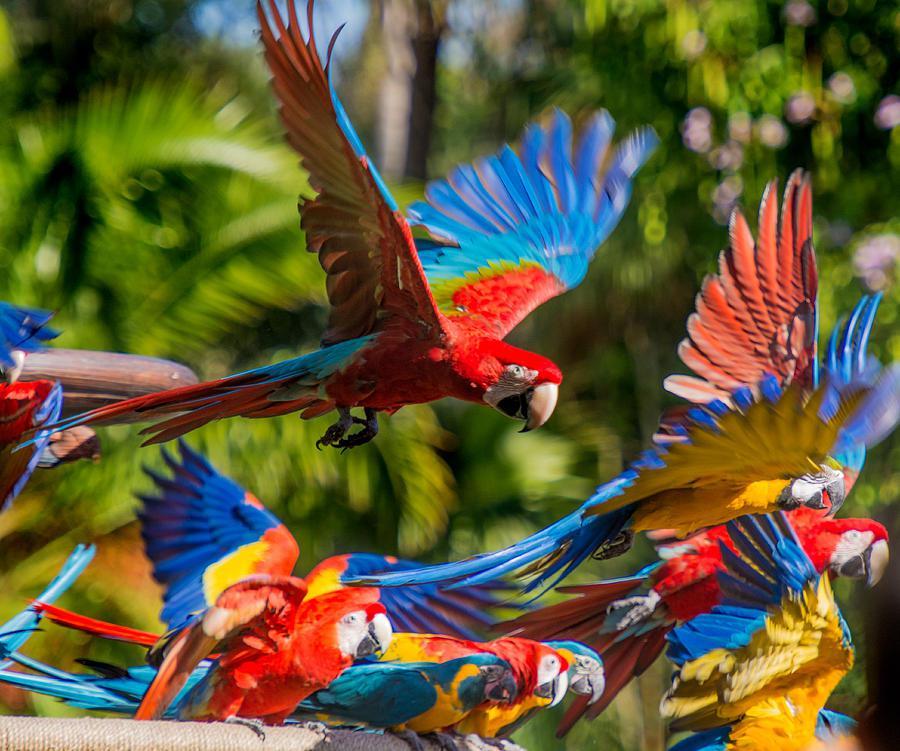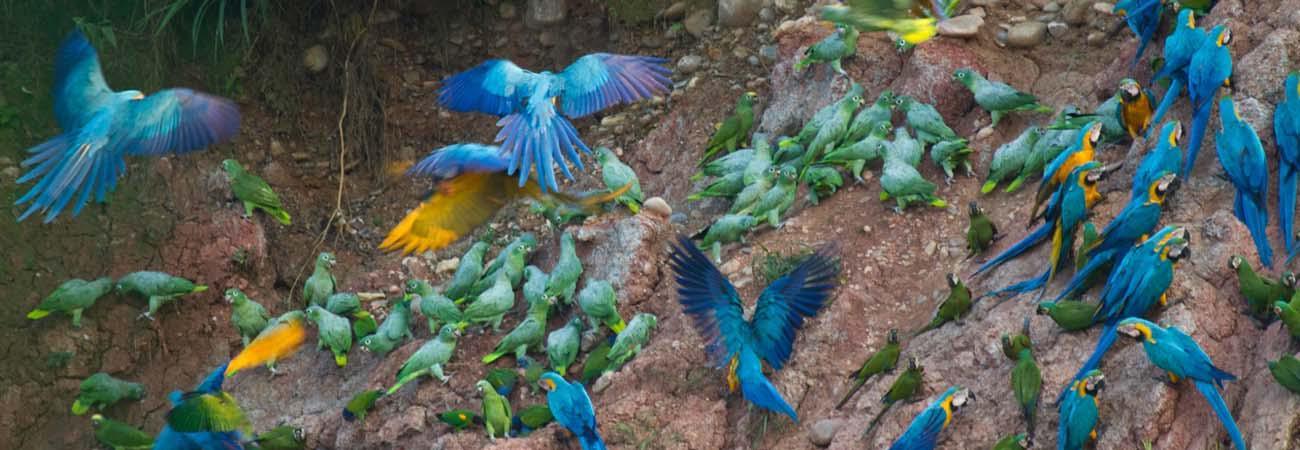The first image is the image on the left, the second image is the image on the right. Analyze the images presented: Is the assertion "The birds on the right are blue, green and orange." valid? Answer yes or no. Yes. 